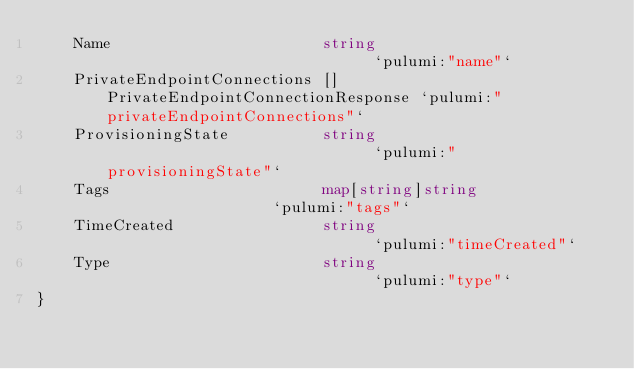<code> <loc_0><loc_0><loc_500><loc_500><_Go_>	Name                       string                              `pulumi:"name"`
	PrivateEndpointConnections []PrivateEndpointConnectionResponse `pulumi:"privateEndpointConnections"`
	ProvisioningState          string                              `pulumi:"provisioningState"`
	Tags                       map[string]string                   `pulumi:"tags"`
	TimeCreated                string                              `pulumi:"timeCreated"`
	Type                       string                              `pulumi:"type"`
}
</code> 